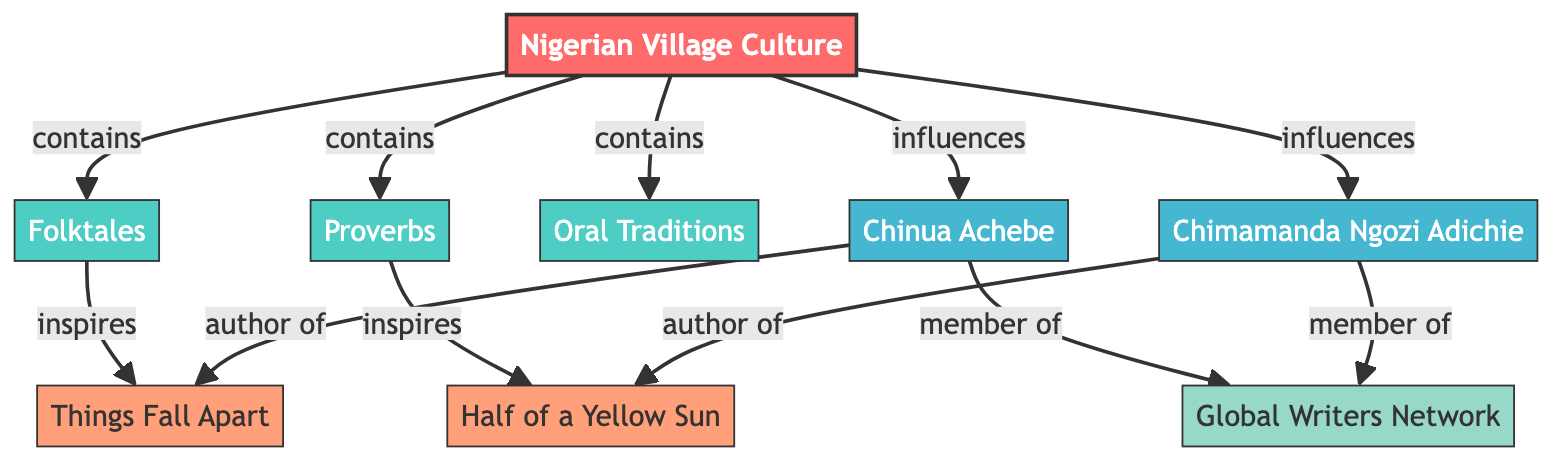What is the root node of this diagram? The diagram starts with one root node, which is labeled "Nigerian Village Culture." It serves as the primary source from which all cultural elements, writers, and works are connected.
Answer: Nigerian Village Culture How many edges are there in total? By counting the connections between nodes, we find there are 12 edges connecting different nodes, representing relationships such as influences and inspires.
Answer: 12 Which cultural element inspires "Half of a Yellow Sun"? The diagram shows a direct connection from "Proverbs" to "Half of a Yellow Sun," indicating that proverbs are part of the cultural heritage that inspired this work.
Answer: Proverbs Who are the two writers influenced by Nigerian village culture? The diagram indicates that both Chinua Achebe and Chimamanda Ngozi Adichie have direct influences stemming from Nigerian village culture, as shown by the arrows leading from the root node to their names.
Answer: Chinua Achebe, Chimamanda Ngozi Adichie What type of relationship exists between "Folktales" and "Things Fall Apart"? The diagram specifies a relationship where "Folktales" inspire "Things Fall Apart," indicating that elements of folktales contributed to the thematic structure of this literary work.
Answer: inspires How many works are attributed to the writers in the diagram? There are two works shown in the diagram: "Things Fall Apart" attributed to Chinua Achebe, and "Half of a Yellow Sun" attributed to Chimamanda Ngozi Adichie, thus totaling two works.
Answer: 2 Which node represents the network of writers inspired by these cultural elements? Within the diagram, "Global Writers Network" functions as a collective representation of writers who are influenced by the cultural aspects outlined in the root node and is connected to the two featured writers.
Answer: Global Writers Network What relationship does "Chinua Achebe" have with "Things Fall Apart"? The diagram shows a clear relationship labeled "author of" connecting Chinua Achebe directly to "Things Fall Apart," meaning he is the author of this work.
Answer: author of How do "Oral Traditions" relate to the "Nigerian Village Culture"? "Oral Traditions" is classified as a cultural element that is contained within the broader concept of "Nigerian Village Culture," indicating it is a significant part of that cultural identity.
Answer: contains 